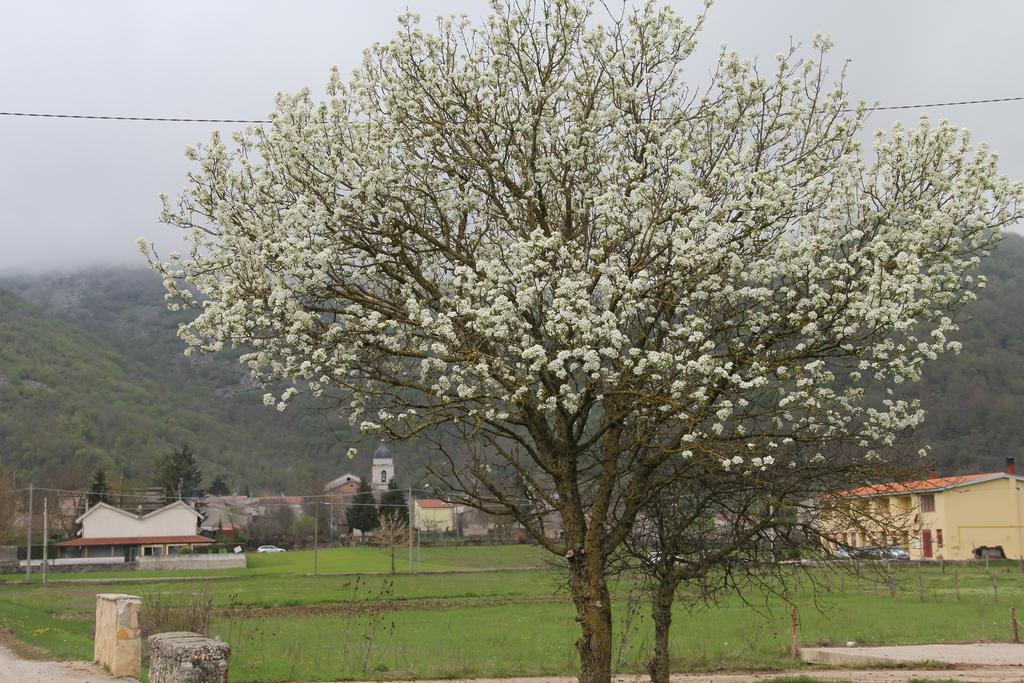What type of vegetation can be seen in the image? There are trees, flowers, grass, and plants in the image. What structures are present in the image? There are poles, buildings, and vehicles in the image. What else can be seen in the background of the image? The sky is visible in the background of the image. How many tomatoes are hanging from the trees in the image? There are no tomatoes present in the image; it features trees, flowers, grass, and plants, but no tomatoes. What type of flower is shown blooming on the haircut in the image? There is no haircut or flower on a haircut present in the image. 